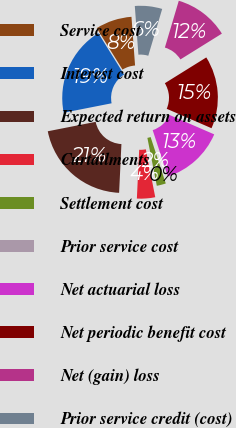Convert chart. <chart><loc_0><loc_0><loc_500><loc_500><pie_chart><fcel>Service cost<fcel>Interest cost<fcel>Expected return on assets<fcel>Curtailments<fcel>Settlement cost<fcel>Prior service cost<fcel>Net actuarial loss<fcel>Net periodic benefit cost<fcel>Net (gain) loss<fcel>Prior service credit (cost)<nl><fcel>7.69%<fcel>19.23%<fcel>21.15%<fcel>3.85%<fcel>1.93%<fcel>0.0%<fcel>13.46%<fcel>15.38%<fcel>11.54%<fcel>5.77%<nl></chart> 